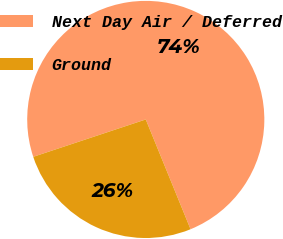<chart> <loc_0><loc_0><loc_500><loc_500><pie_chart><fcel>Next Day Air / Deferred<fcel>Ground<nl><fcel>73.94%<fcel>26.06%<nl></chart> 